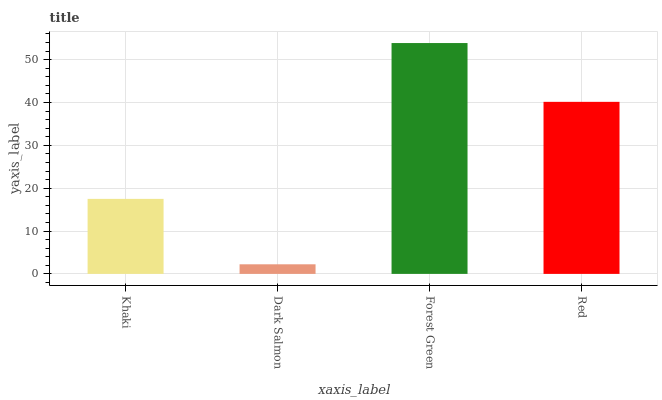Is Dark Salmon the minimum?
Answer yes or no. Yes. Is Forest Green the maximum?
Answer yes or no. Yes. Is Forest Green the minimum?
Answer yes or no. No. Is Dark Salmon the maximum?
Answer yes or no. No. Is Forest Green greater than Dark Salmon?
Answer yes or no. Yes. Is Dark Salmon less than Forest Green?
Answer yes or no. Yes. Is Dark Salmon greater than Forest Green?
Answer yes or no. No. Is Forest Green less than Dark Salmon?
Answer yes or no. No. Is Red the high median?
Answer yes or no. Yes. Is Khaki the low median?
Answer yes or no. Yes. Is Forest Green the high median?
Answer yes or no. No. Is Dark Salmon the low median?
Answer yes or no. No. 